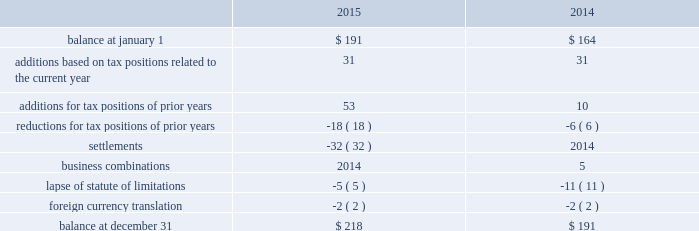Uncertain tax positions the following is a reconciliation of the company's beginning and ending amount of uncertain tax positions ( in millions ) : .
The company's liability for uncertain tax positions as of december 31 , 2015 , 2014 , and 2013 , includes $ 180 million , $ 154 million , and $ 141 million , respectively , related to amounts that would impact the effective tax rate if recognized .
It is possible that the amount of unrecognized tax benefits may change in the next twelve months ; however , we do not expect the change to have a significant impact on our consolidated statements of income or consolidated balance sheets .
These changes may be the result of settlements of ongoing audits .
At this time , an estimate of the range of the reasonably possible outcomes within the twelve months cannot be made .
The company recognizes interest and penalties related to uncertain tax positions in its provision for income taxes .
The company accrued potential interest and penalties of $ 2 million , $ 4 million , and $ 2 million in 2015 , 2014 , and 2013 , respectively .
The company recorded a liability for interest and penalties of $ 33 million , $ 31 million , and $ 27 million as of december 31 , 2015 , 2014 , and 2013 , respectively .
The company and its subsidiaries file income tax returns in their respective jurisdictions .
The company has substantially concluded all u.s .
Federal income tax matters for years through 2007 .
Material u.s .
State and local income tax jurisdiction examinations have been concluded for years through 2005 .
The company has concluded income tax examinations in its primary non-u.s .
Jurisdictions through 2005 .
Shareholders' equity distributable reserves as a u.k .
Incorporated company , the company is required under u.k .
Law to have available "distributable reserves" to make share repurchases or pay dividends to shareholders .
Distributable reserves may be created through the earnings of the u.k .
Parent company and , amongst other methods , through a reduction in share capital approved by the english companies court .
Distributable reserves are not linked to a u.s .
Gaap reported amount ( e.g. , retained earnings ) .
As of december 31 , 2015 and 2014 , the company had distributable reserves in excess of $ 2.1 billion and $ 4.0 billion , respectively .
Ordinary shares in april 2012 , the company's board of directors authorized a share repurchase program under which up to $ 5.0 billion of class a ordinary shares may be repurchased ( "2012 share repurchase program" ) .
In november 2014 , the company's board of directors authorized a new $ 5.0 billion share repurchase program in addition to the existing program ( "2014 share repurchase program" and , together , the "repurchase programs" ) .
Under each program , shares may be repurchased through the open market or in privately negotiated transactions , based on prevailing market conditions , funded from available capital .
During 2015 , the company repurchased 16.0 million shares at an average price per share of $ 97.04 for a total cost of $ 1.6 billion under the repurchase programs .
During 2014 , the company repurchased 25.8 million shares at an average price per share of $ 87.18 for a total cost of $ 2.3 billion under the 2012 share repurchase plan .
In august 2015 , the $ 5 billion of class a ordinary shares authorized under the 2012 share repurchase program was exhausted .
At december 31 , 2015 , the remaining authorized amount for share repurchase under the 2014 share repurchase program is $ 4.1 billion .
Under the repurchase programs , the company repurchased a total of 78.1 million shares for an aggregate cost of $ 5.9 billion. .
What is the difference between the liability for uncertain tax positions as of december 31 , 2015 and the balance of the uncertain tax positions at december 31 , 2015 , ( in millions )? 
Computations: (218 - 180)
Answer: 38.0. Uncertain tax positions the following is a reconciliation of the company's beginning and ending amount of uncertain tax positions ( in millions ) : .
The company's liability for uncertain tax positions as of december 31 , 2015 , 2014 , and 2013 , includes $ 180 million , $ 154 million , and $ 141 million , respectively , related to amounts that would impact the effective tax rate if recognized .
It is possible that the amount of unrecognized tax benefits may change in the next twelve months ; however , we do not expect the change to have a significant impact on our consolidated statements of income or consolidated balance sheets .
These changes may be the result of settlements of ongoing audits .
At this time , an estimate of the range of the reasonably possible outcomes within the twelve months cannot be made .
The company recognizes interest and penalties related to uncertain tax positions in its provision for income taxes .
The company accrued potential interest and penalties of $ 2 million , $ 4 million , and $ 2 million in 2015 , 2014 , and 2013 , respectively .
The company recorded a liability for interest and penalties of $ 33 million , $ 31 million , and $ 27 million as of december 31 , 2015 , 2014 , and 2013 , respectively .
The company and its subsidiaries file income tax returns in their respective jurisdictions .
The company has substantially concluded all u.s .
Federal income tax matters for years through 2007 .
Material u.s .
State and local income tax jurisdiction examinations have been concluded for years through 2005 .
The company has concluded income tax examinations in its primary non-u.s .
Jurisdictions through 2005 .
Shareholders' equity distributable reserves as a u.k .
Incorporated company , the company is required under u.k .
Law to have available "distributable reserves" to make share repurchases or pay dividends to shareholders .
Distributable reserves may be created through the earnings of the u.k .
Parent company and , amongst other methods , through a reduction in share capital approved by the english companies court .
Distributable reserves are not linked to a u.s .
Gaap reported amount ( e.g. , retained earnings ) .
As of december 31 , 2015 and 2014 , the company had distributable reserves in excess of $ 2.1 billion and $ 4.0 billion , respectively .
Ordinary shares in april 2012 , the company's board of directors authorized a share repurchase program under which up to $ 5.0 billion of class a ordinary shares may be repurchased ( "2012 share repurchase program" ) .
In november 2014 , the company's board of directors authorized a new $ 5.0 billion share repurchase program in addition to the existing program ( "2014 share repurchase program" and , together , the "repurchase programs" ) .
Under each program , shares may be repurchased through the open market or in privately negotiated transactions , based on prevailing market conditions , funded from available capital .
During 2015 , the company repurchased 16.0 million shares at an average price per share of $ 97.04 for a total cost of $ 1.6 billion under the repurchase programs .
During 2014 , the company repurchased 25.8 million shares at an average price per share of $ 87.18 for a total cost of $ 2.3 billion under the 2012 share repurchase plan .
In august 2015 , the $ 5 billion of class a ordinary shares authorized under the 2012 share repurchase program was exhausted .
At december 31 , 2015 , the remaining authorized amount for share repurchase under the 2014 share repurchase program is $ 4.1 billion .
Under the repurchase programs , the company repurchased a total of 78.1 million shares for an aggregate cost of $ 5.9 billion. .
What was the ratio of the share repurchase in 2014 to 2015? 
Computations: (25.8 / 16.0)
Answer: 1.6125. 